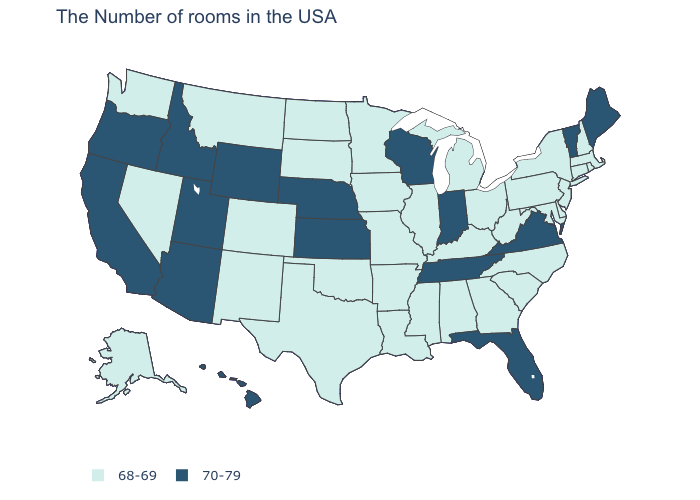Does Maryland have the highest value in the South?
Keep it brief. No. Does the map have missing data?
Concise answer only. No. What is the value of Texas?
Be succinct. 68-69. Does Wyoming have the highest value in the USA?
Concise answer only. Yes. Does the first symbol in the legend represent the smallest category?
Quick response, please. Yes. Does Arkansas have the same value as Florida?
Keep it brief. No. Which states hav the highest value in the MidWest?
Be succinct. Indiana, Wisconsin, Kansas, Nebraska. Name the states that have a value in the range 70-79?
Write a very short answer. Maine, Vermont, Virginia, Florida, Indiana, Tennessee, Wisconsin, Kansas, Nebraska, Wyoming, Utah, Arizona, Idaho, California, Oregon, Hawaii. What is the value of Connecticut?
Keep it brief. 68-69. What is the lowest value in the West?
Give a very brief answer. 68-69. Does Vermont have the lowest value in the USA?
Be succinct. No. Does Massachusetts have the same value as Virginia?
Short answer required. No. Among the states that border California , does Oregon have the lowest value?
Concise answer only. No. What is the lowest value in the USA?
Quick response, please. 68-69. Does Texas have the highest value in the USA?
Quick response, please. No. 